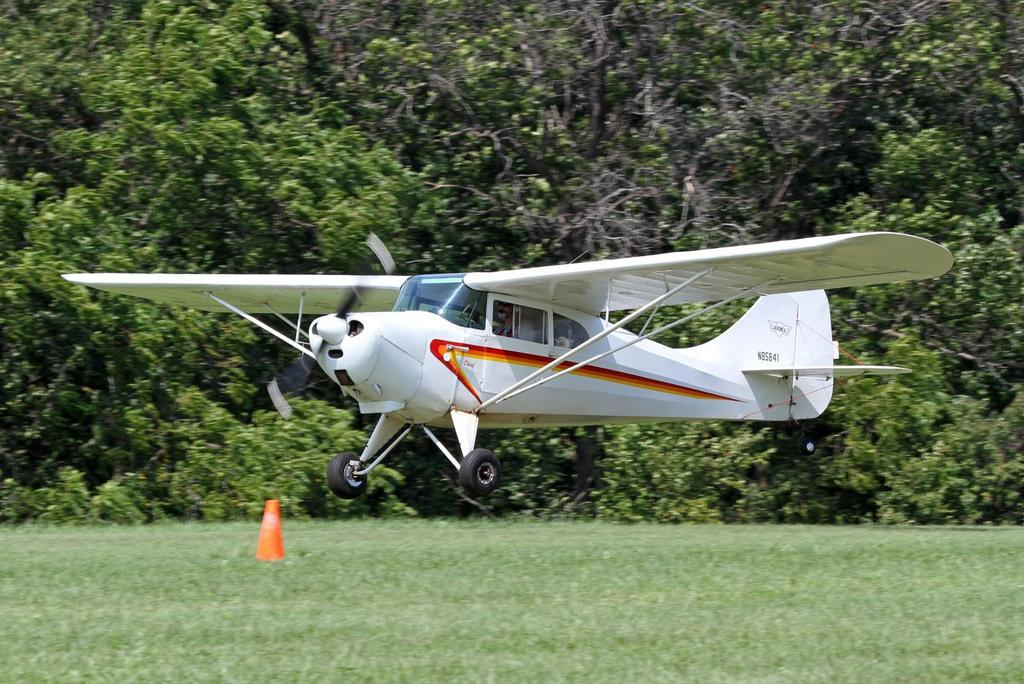What is the person in the image doing? There is a person riding an aircraft in the image. Where is the aircraft located? The aircraft is in the air. What can be seen at the bottom of the image? There is grass visible at the bottom of the image, and there is a cone as well. What is visible in the background of the image? There are trees and plants in the background of the image. What type of curtain can be seen hanging from the aircraft in the image? There is no curtain visible hanging from the aircraft in the image. What kind of feast is being prepared in the background of the image? There is no feast or any indication of food preparation visible in the image. 